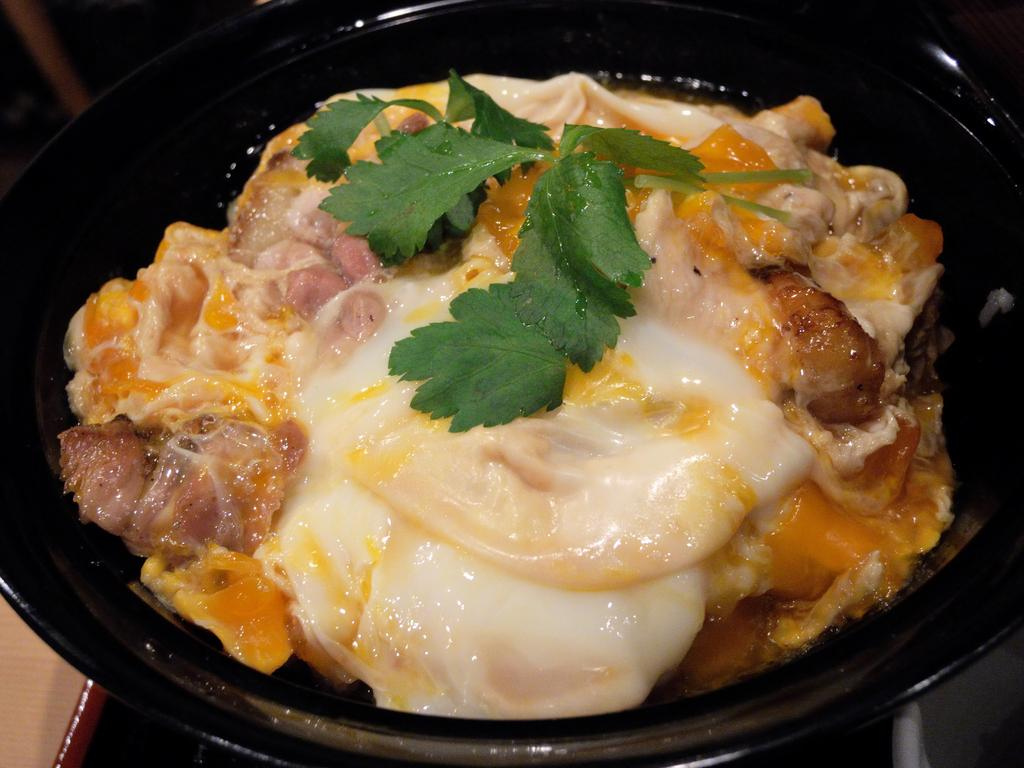What is in the bowl that is visible in the image? There is a bowl in the image, and it contains omelettes. Are there any other ingredients or items in the bowl? Yes, the bowl also contains flesh and leaves. What type of authority is depicted in the image? There is no authority figure present in the image; it features a bowl containing omelettes, flesh, and leaves. How does the wealth of the individuals in the image compare to each other? There are no individuals present in the image, only a bowl containing omelettes, flesh, and leaves. 